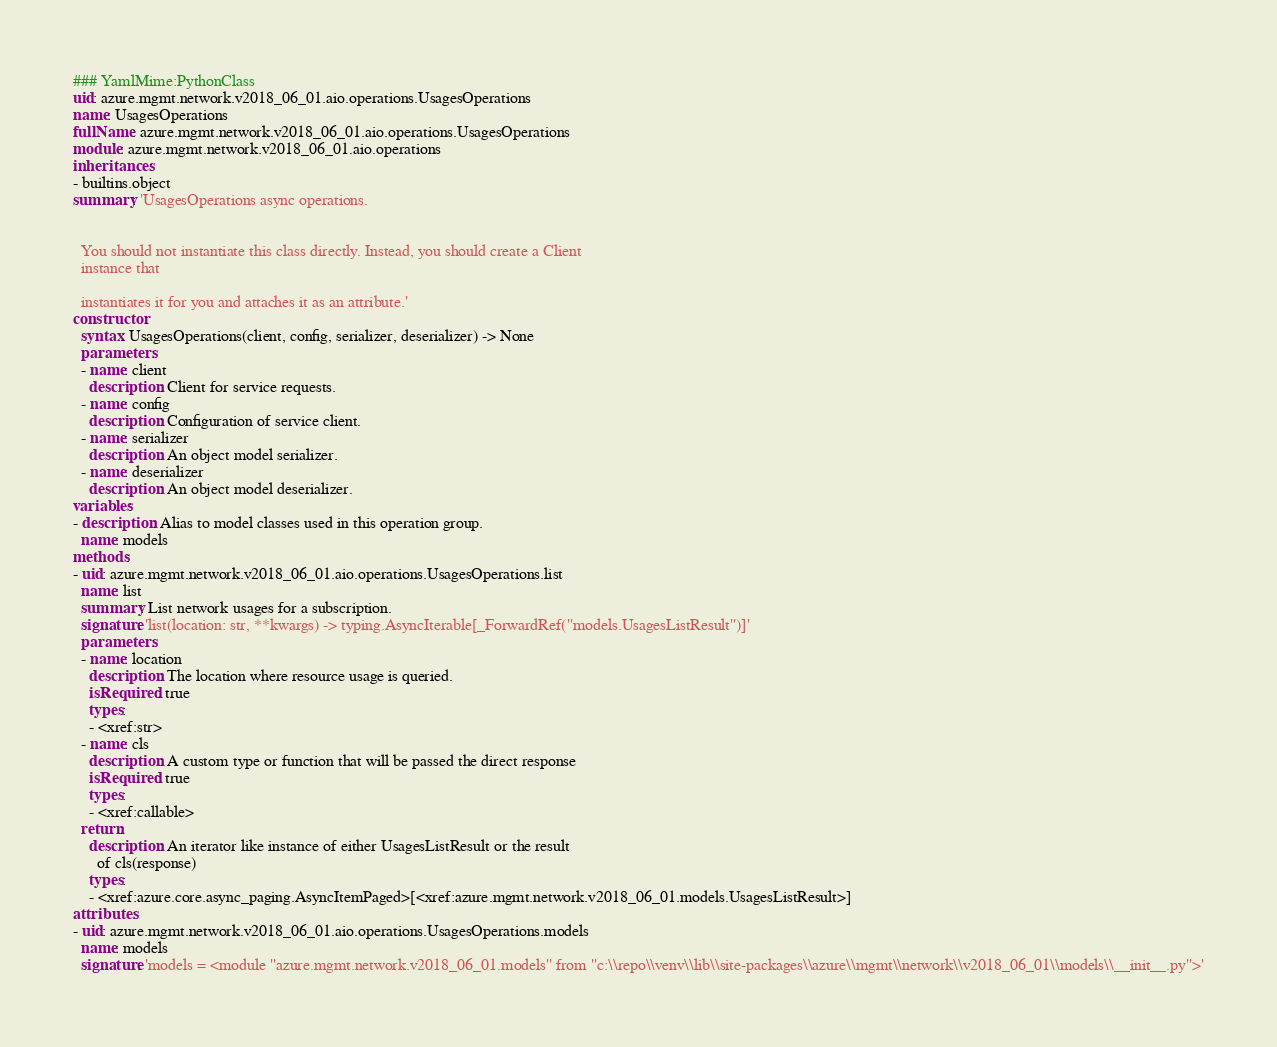<code> <loc_0><loc_0><loc_500><loc_500><_YAML_>### YamlMime:PythonClass
uid: azure.mgmt.network.v2018_06_01.aio.operations.UsagesOperations
name: UsagesOperations
fullName: azure.mgmt.network.v2018_06_01.aio.operations.UsagesOperations
module: azure.mgmt.network.v2018_06_01.aio.operations
inheritances:
- builtins.object
summary: 'UsagesOperations async operations.


  You should not instantiate this class directly. Instead, you should create a Client
  instance that

  instantiates it for you and attaches it as an attribute.'
constructor:
  syntax: UsagesOperations(client, config, serializer, deserializer) -> None
  parameters:
  - name: client
    description: Client for service requests.
  - name: config
    description: Configuration of service client.
  - name: serializer
    description: An object model serializer.
  - name: deserializer
    description: An object model deserializer.
variables:
- description: Alias to model classes used in this operation group.
  name: models
methods:
- uid: azure.mgmt.network.v2018_06_01.aio.operations.UsagesOperations.list
  name: list
  summary: List network usages for a subscription.
  signature: 'list(location: str, **kwargs) -> typing.AsyncIterable[_ForwardRef(''models.UsagesListResult'')]'
  parameters:
  - name: location
    description: The location where resource usage is queried.
    isRequired: true
    types:
    - <xref:str>
  - name: cls
    description: A custom type or function that will be passed the direct response
    isRequired: true
    types:
    - <xref:callable>
  return:
    description: An iterator like instance of either UsagesListResult or the result
      of cls(response)
    types:
    - <xref:azure.core.async_paging.AsyncItemPaged>[<xref:azure.mgmt.network.v2018_06_01.models.UsagesListResult>]
attributes:
- uid: azure.mgmt.network.v2018_06_01.aio.operations.UsagesOperations.models
  name: models
  signature: 'models = <module ''azure.mgmt.network.v2018_06_01.models'' from ''c:\\repo\\venv\\lib\\site-packages\\azure\\mgmt\\network\\v2018_06_01\\models\\__init__.py''>'
</code> 